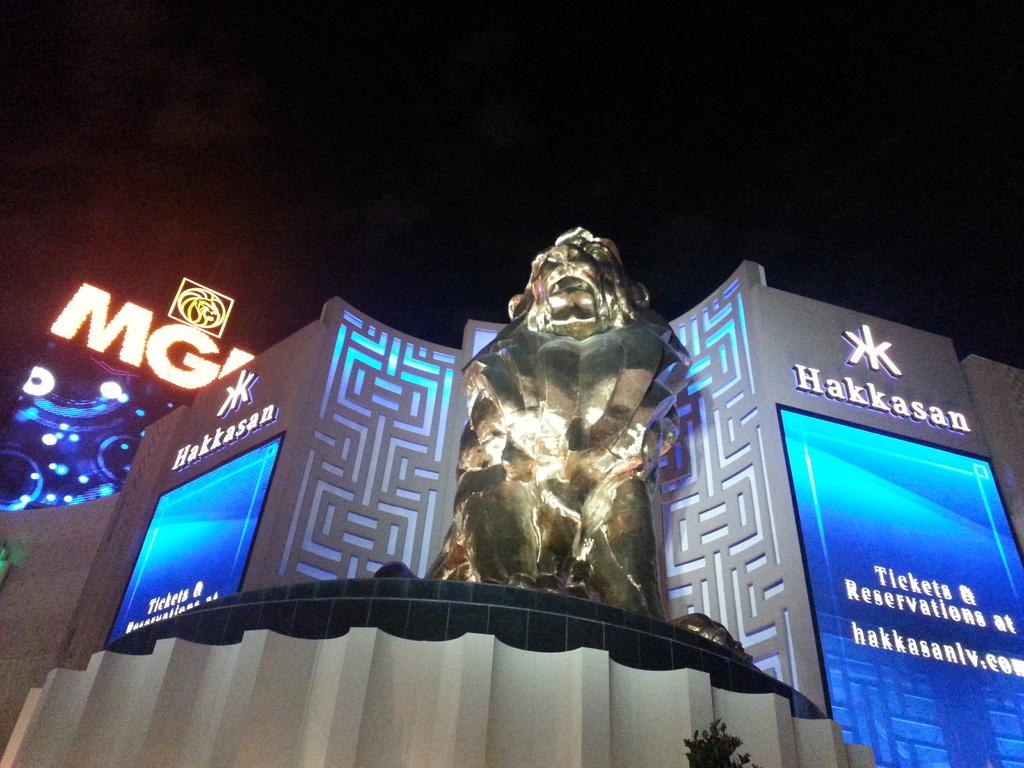<image>
Give a short and clear explanation of the subsequent image. The front of the Hakkasan building with large LCD screens telling you where to get Tickets & Reservations. 